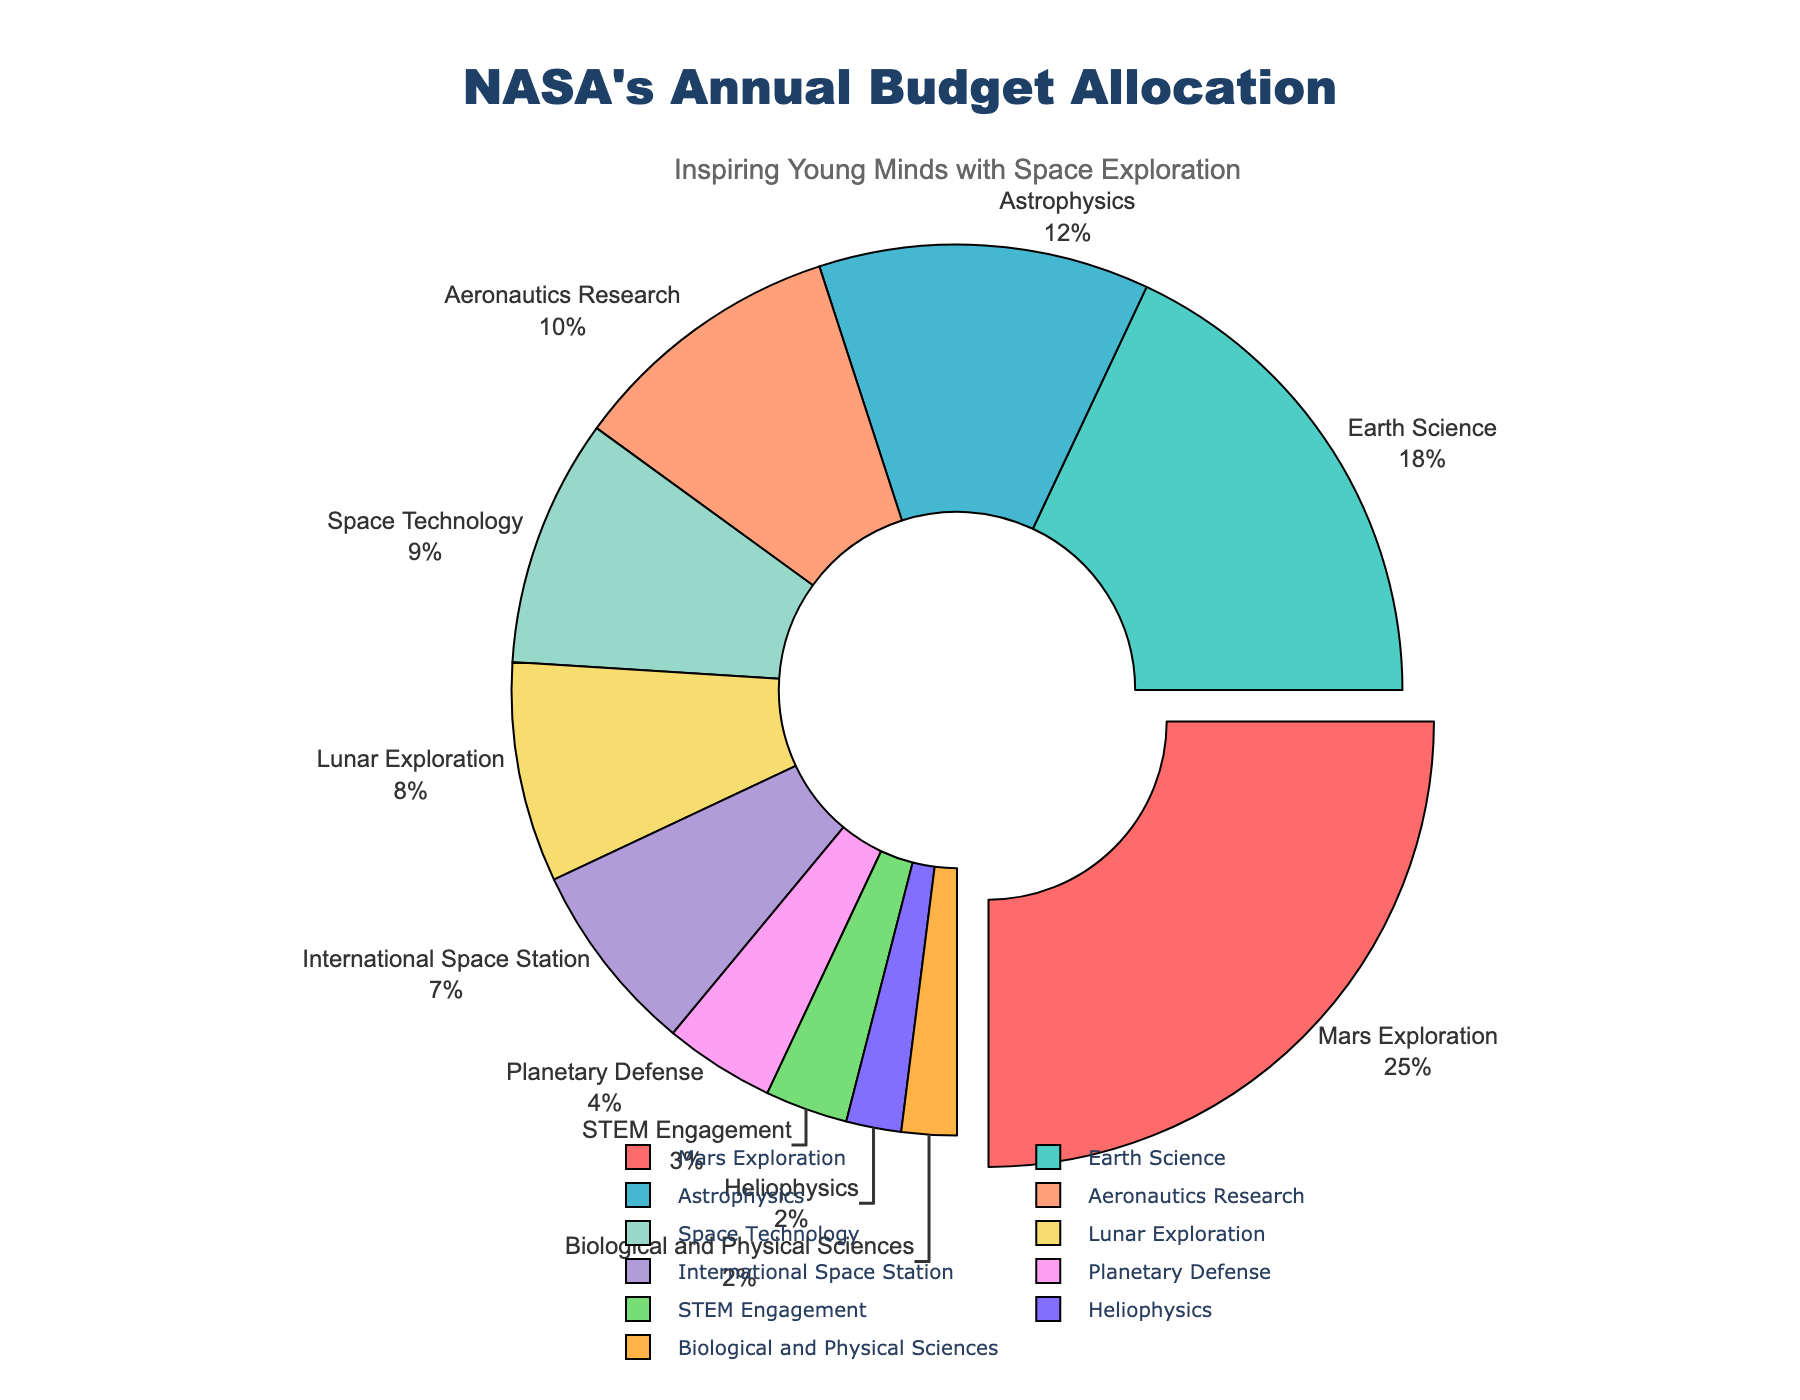what program has the highest budget allocation? The program with the highest budget allocation can be identified by observing the largest segment in the pie chart, which is located at the top and slightly pulled out. This segment is labeled "Mars Exploration".
Answer: Mars Exploration What is the combined budget allocation for Earth Science and Astrophysics? To find the combined budget allocation, we sum the allocations for both programs, which are given as 18% for Earth Science and 12% for Astrophysics. So, 18% + 12% = 30%.
Answer: 30% Which program receives less budget allocation: Lunar Exploration or Space Technology? By comparing the segments labeled "Lunar Exploration" and "Space Technology", we see that Lunar Exploration has an 8% allocation, whereas Space Technology has a 9% allocation. Lunar Exploration receives less budget allocation.
Answer: Lunar Exploration How much more budget allocation does Mars Exploration receive compared to the International Space Station? Mars Exploration receives 25% of the budget while the International Space Station receives 7%. The difference is 25% - 7% = 18%.
Answer: 18% What percentage of the budget is allocated to programs receiving less than 5% each? The programs receiving less than 5% each are Planetary Defense, STEM Engagement, Heliophysics, and Biological and Physical Sciences. Their allocations are 4%, 3%, 2%, and 2%, respectively. Adding these together: 4% + 3% + 2% + 2% = 11%.
Answer: 11% Which program has the smallest budget allocation and what is that percentage? The smallest segment in the pie chart corresponds to the label "Biological and Physical Sciences", which has an allocation of 2%.
Answer: Biological and Physical Sciences, 2% Is the budget allocation for Aeronautics Research higher or lower than that for Astrophysics? By comparing the segments for "Aeronautics Research" and "Astrophysics", the budget allocation for Aeronautics Research is 10%, which is lower than the 12% for Astrophysics.
Answer: Lower What is the average budget allocation of Aeronautics Research, Space Technology, and Lunar Exploration? The budget allocations are 10% for Aeronautics Research, 9% for Space Technology, and 8% for Lunar Exploration. The average is calculated as (10% + 9% + 8%) / 3 = 9%.
Answer: 9% If the budget for Mars Exploration and Earth Science were combined, how much more would it be compared to the total budget for Astrophysics and Aeronautics Research combined? Adding Mars Exploration and Earth Science: 25% + 18% = 43%. Adding Astrophysics and Aeronautics Research: 12% + 10% = 22%. The difference is 43% - 22% = 21%.
Answer: 21% How does the budget allocation for Planetary Defense compare visually with that for STEM Engagement? Visually, the segment for Planetary Defense is slightly larger than the segment for STEM Engagement, reflecting their respective budget allocations of 4% and 3%.
Answer: Larger 